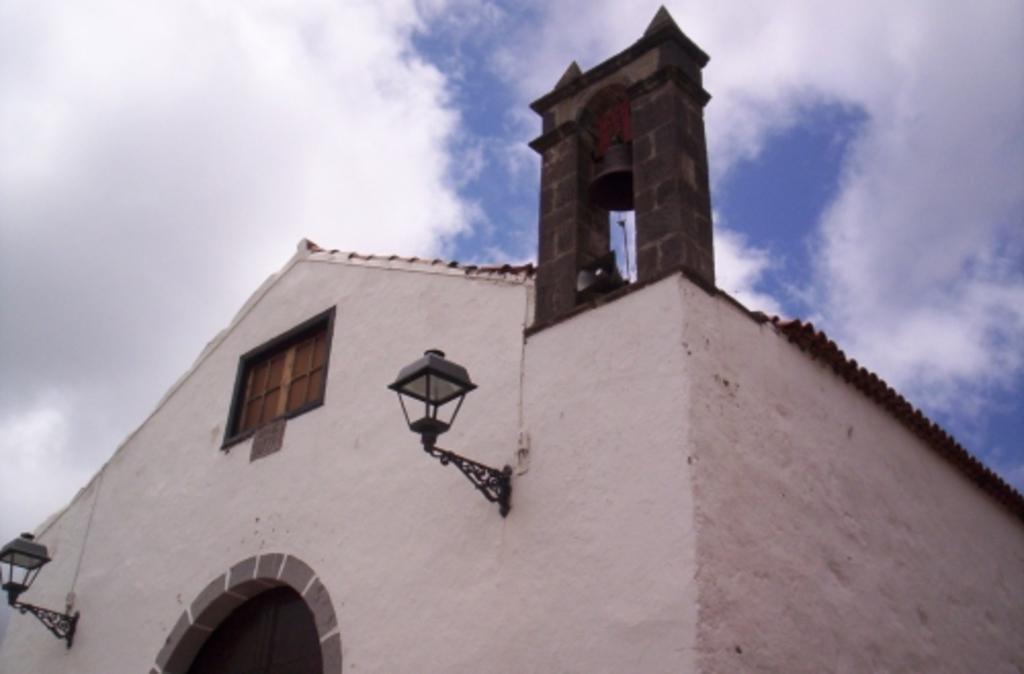Please provide a concise description of this image. In this image, we can see a roof house. There are lights on the wall. There are clouds in the sky. 